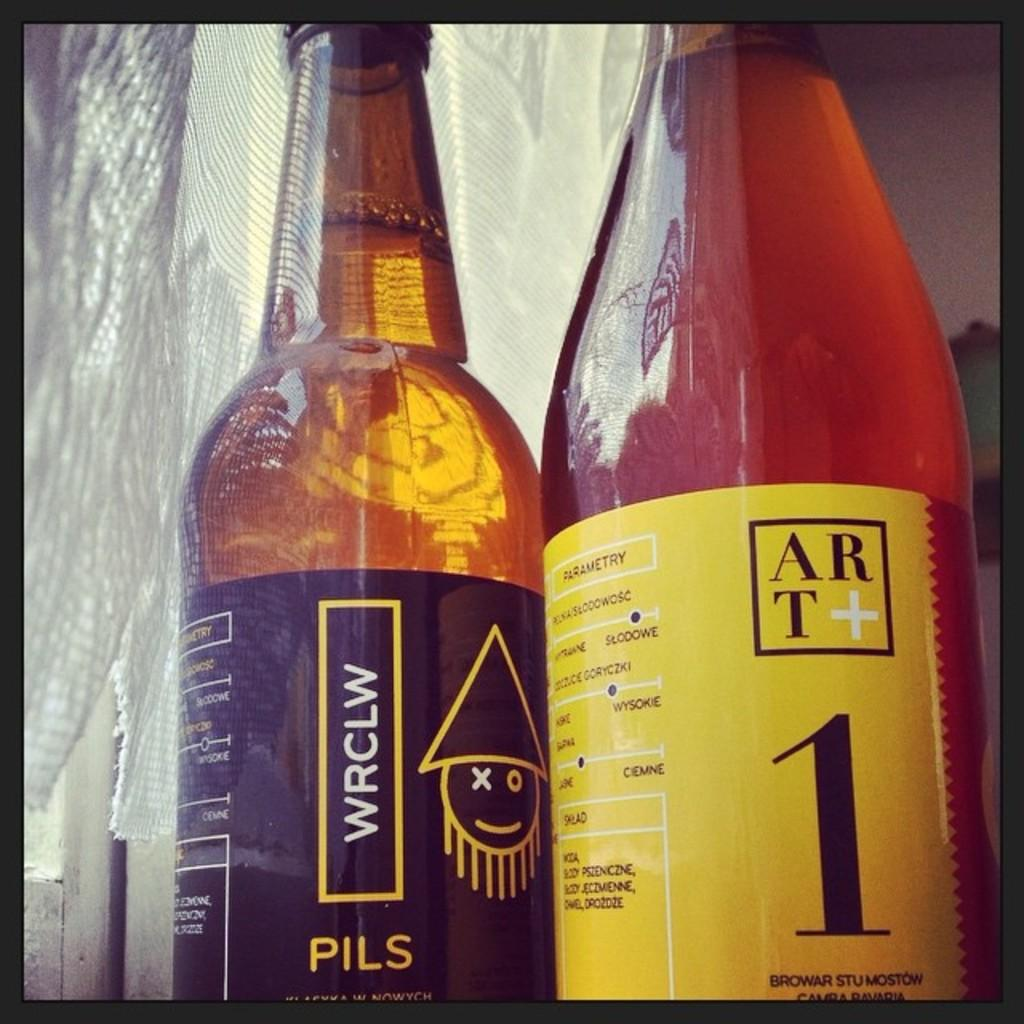<image>
Relay a brief, clear account of the picture shown. Two bottles side by side, one of which describes itself as Pils. 